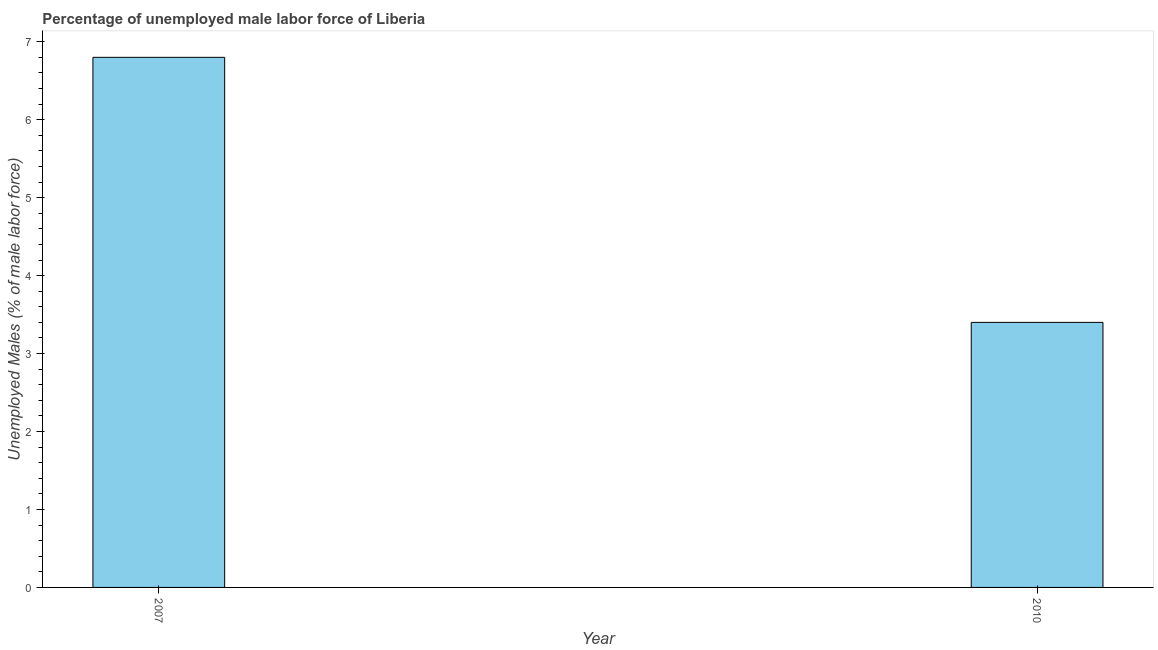What is the title of the graph?
Provide a short and direct response. Percentage of unemployed male labor force of Liberia. What is the label or title of the X-axis?
Your answer should be compact. Year. What is the label or title of the Y-axis?
Ensure brevity in your answer.  Unemployed Males (% of male labor force). What is the total unemployed male labour force in 2010?
Your answer should be compact. 3.4. Across all years, what is the maximum total unemployed male labour force?
Keep it short and to the point. 6.8. Across all years, what is the minimum total unemployed male labour force?
Give a very brief answer. 3.4. In which year was the total unemployed male labour force maximum?
Your answer should be compact. 2007. What is the sum of the total unemployed male labour force?
Your answer should be very brief. 10.2. What is the median total unemployed male labour force?
Offer a terse response. 5.1. In how many years, is the total unemployed male labour force greater than 3.2 %?
Keep it short and to the point. 2. Do a majority of the years between 2007 and 2010 (inclusive) have total unemployed male labour force greater than 0.8 %?
Your answer should be compact. Yes. In how many years, is the total unemployed male labour force greater than the average total unemployed male labour force taken over all years?
Ensure brevity in your answer.  1. How many bars are there?
Keep it short and to the point. 2. What is the difference between two consecutive major ticks on the Y-axis?
Your answer should be very brief. 1. Are the values on the major ticks of Y-axis written in scientific E-notation?
Your answer should be very brief. No. What is the Unemployed Males (% of male labor force) of 2007?
Make the answer very short. 6.8. What is the Unemployed Males (% of male labor force) of 2010?
Provide a short and direct response. 3.4. What is the difference between the Unemployed Males (% of male labor force) in 2007 and 2010?
Provide a short and direct response. 3.4. What is the ratio of the Unemployed Males (% of male labor force) in 2007 to that in 2010?
Make the answer very short. 2. 